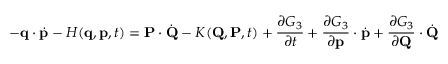Convert formula to latex. <formula><loc_0><loc_0><loc_500><loc_500>- q \cdot { \dot { p } } - H ( q , p , t ) = P \cdot { \dot { Q } } - K ( Q , P , t ) + { \frac { \partial G _ { 3 } } { \partial t } } + { \frac { \partial G _ { 3 } } { \partial p } } \cdot { \dot { p } } + { \frac { \partial G _ { 3 } } { \partial Q } } \cdot { \dot { Q } }</formula> 